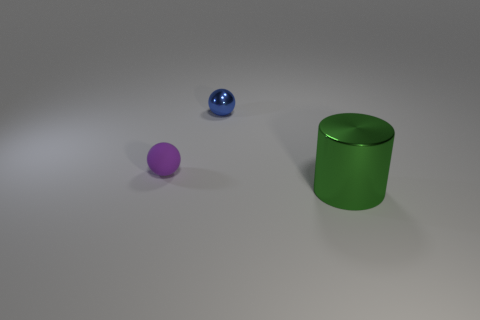Add 2 large green cylinders. How many objects exist? 5 Subtract all cylinders. How many objects are left? 2 Add 2 tiny green metal cylinders. How many tiny green metal cylinders exist? 2 Subtract 0 red cylinders. How many objects are left? 3 Subtract all purple balls. Subtract all big brown spheres. How many objects are left? 2 Add 2 small metallic balls. How many small metallic balls are left? 3 